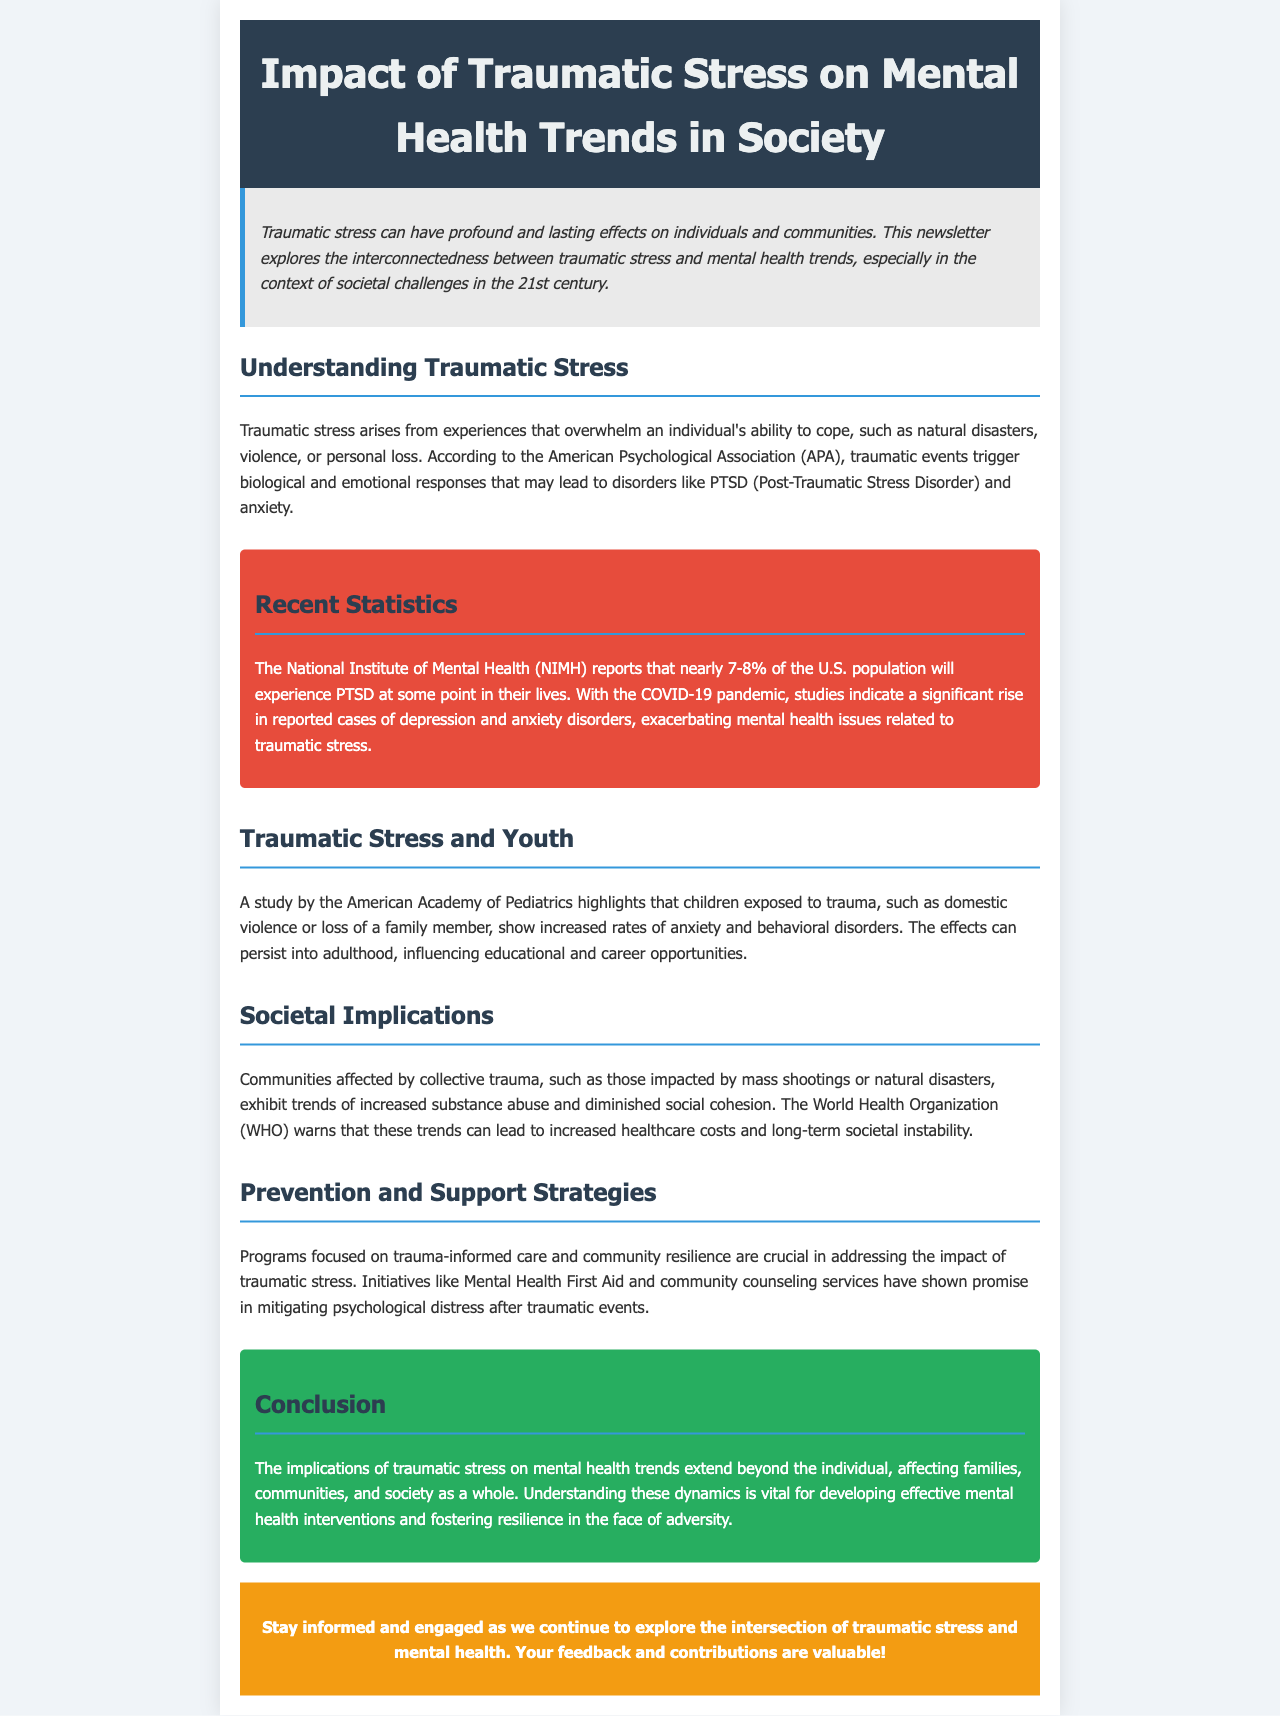What is PTSD? PTSD stands for Post-Traumatic Stress Disorder, which is a disorder that can arise from traumatic stress.
Answer: Post-Traumatic Stress Disorder What percentage of the U.S. population experiences PTSD? According to the NIMH, nearly 7-8% of the U.S. population will experience PTSD at some point in their lives.
Answer: 7-8% Which organization warns about the implications of traumatic stress on healthcare costs? The World Health Organization (WHO) warns about trends in mental health leading to increased healthcare costs.
Answer: World Health Organization What kind of programs are crucial for addressing traumatic stress? Programs focused on trauma-informed care and community resilience are crucial in addressing the impact of traumatic stress.
Answer: Trauma-informed care How do children exposed to trauma generally respond? Children exposed to trauma show increased rates of anxiety and behavioral disorders, according to the American Academy of Pediatrics.
Answer: Increased rates of anxiety and behavioral disorders 